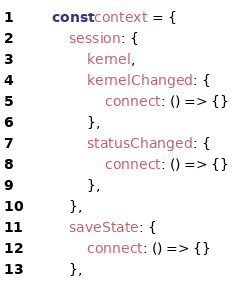Convert code to text. <code><loc_0><loc_0><loc_500><loc_500><_JavaScript_>
        const context = { 
            session: {
                kernel,
                kernelChanged: {
                    connect: () => {}
                },
                statusChanged: {
                    connect: () => {}
                },
            },
            saveState: {
                connect: () => {}
            },</code> 